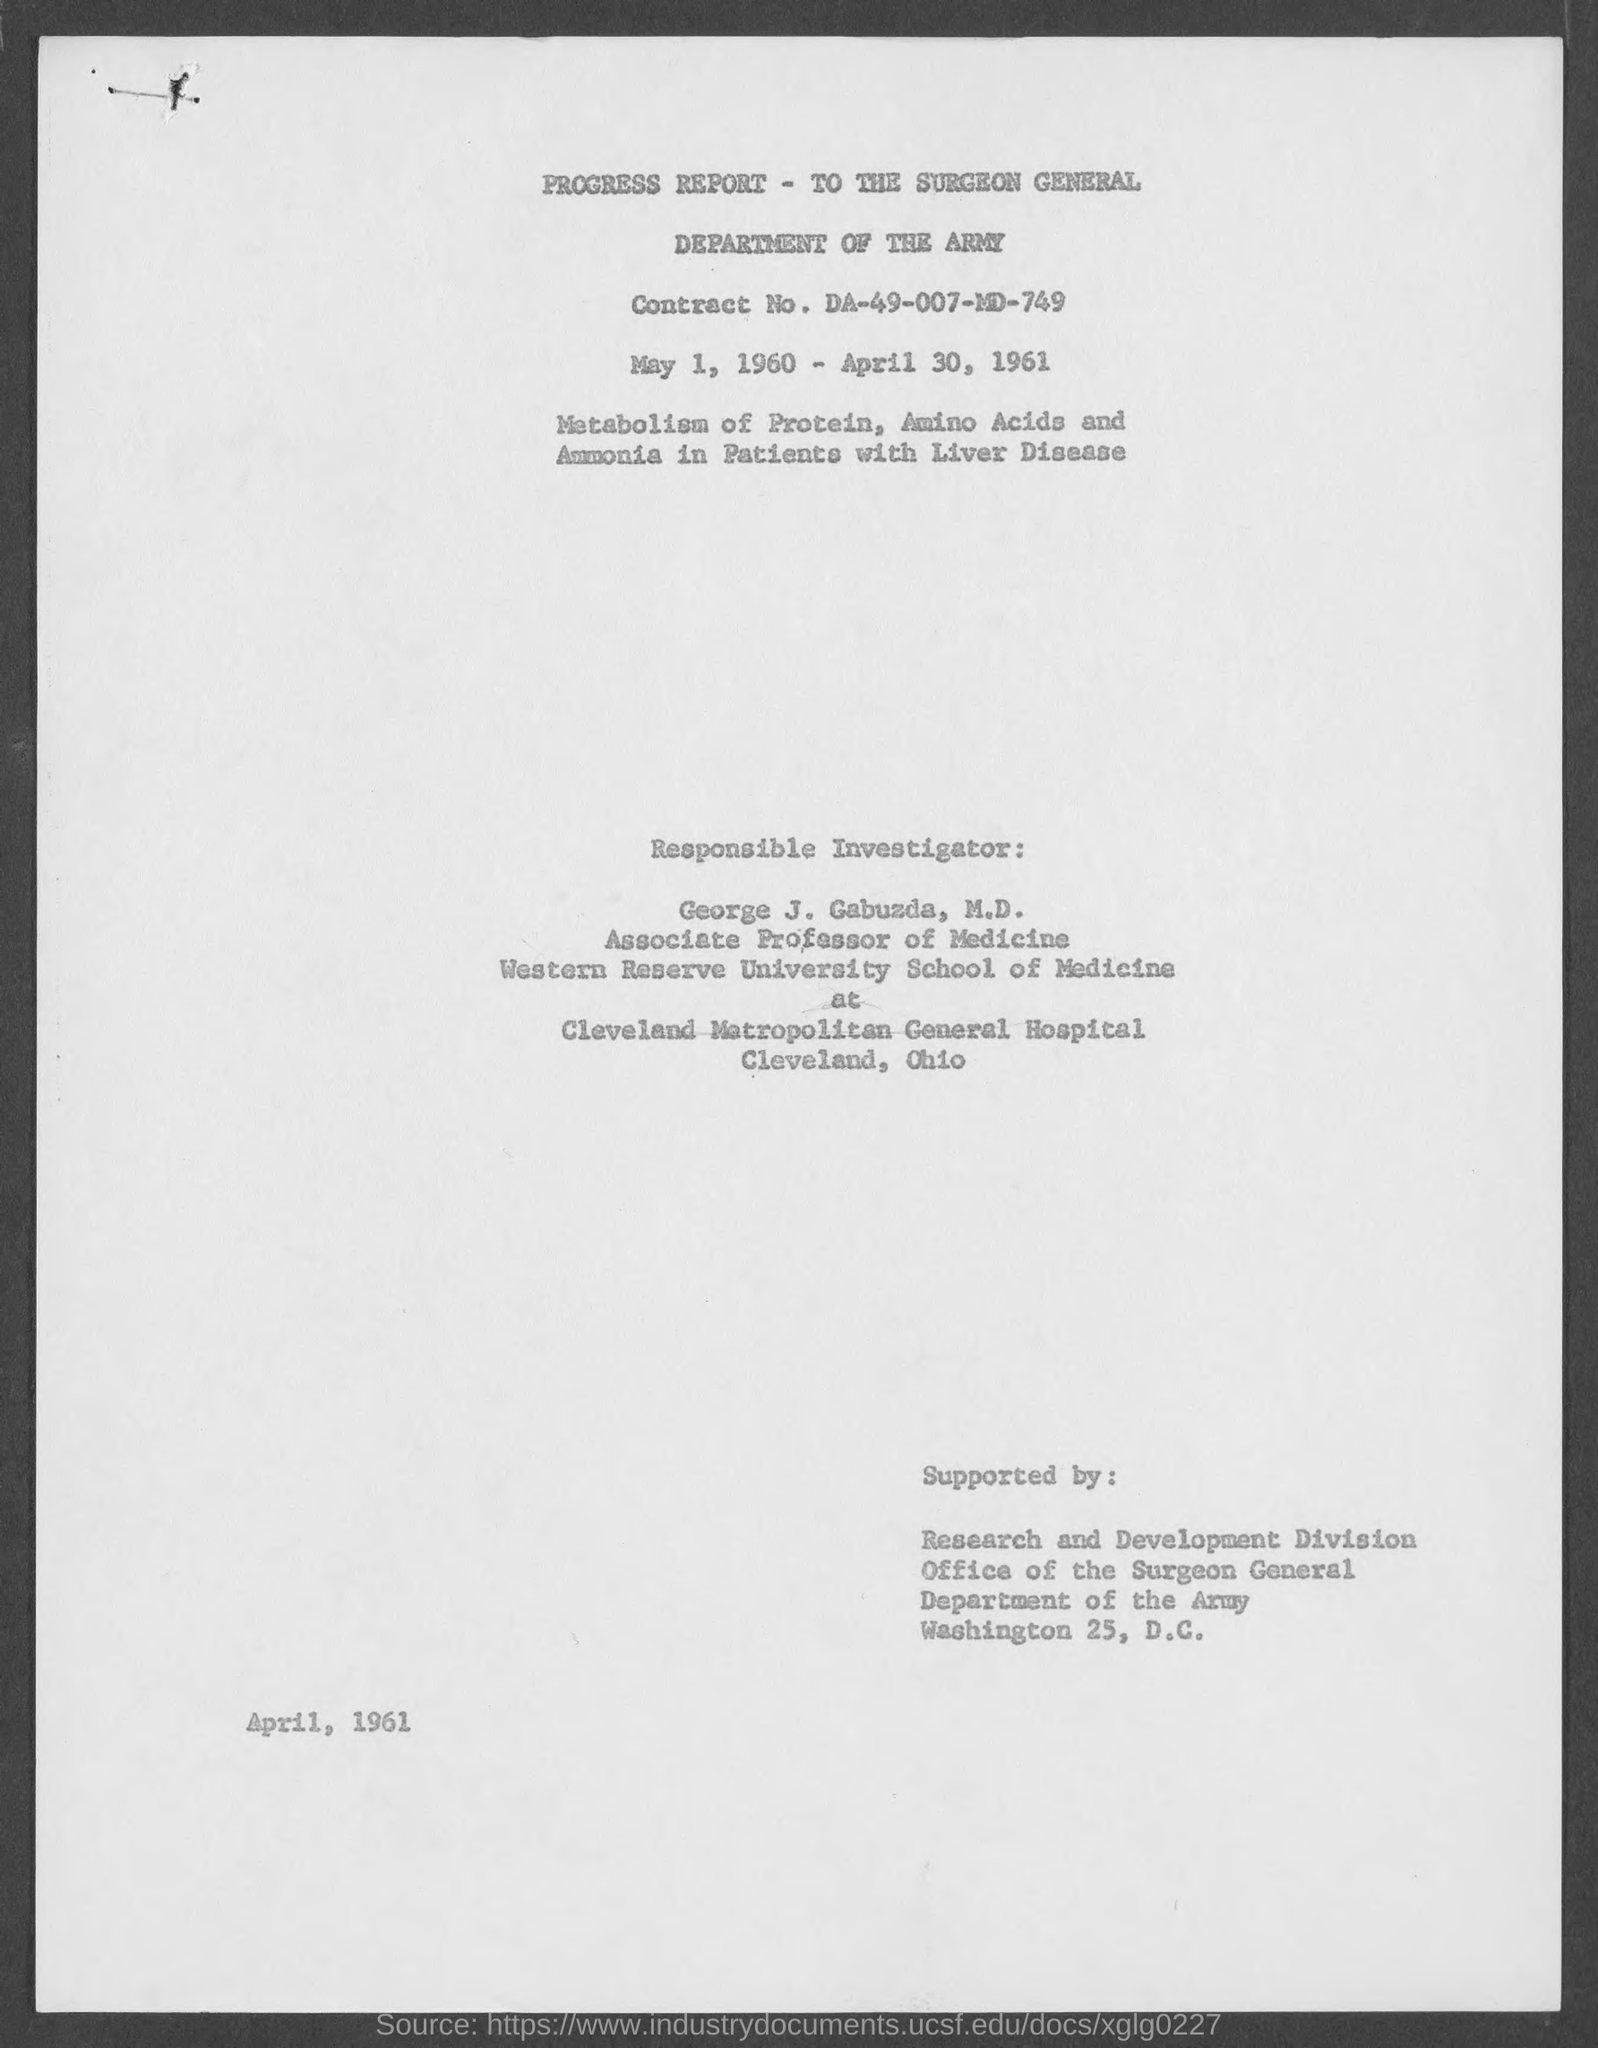What is Contract No.?
Your response must be concise. DA-49-007-MD-749. What is the department mentioned in the document?
Make the answer very short. DEPARTMENT OF THE ARMY. 